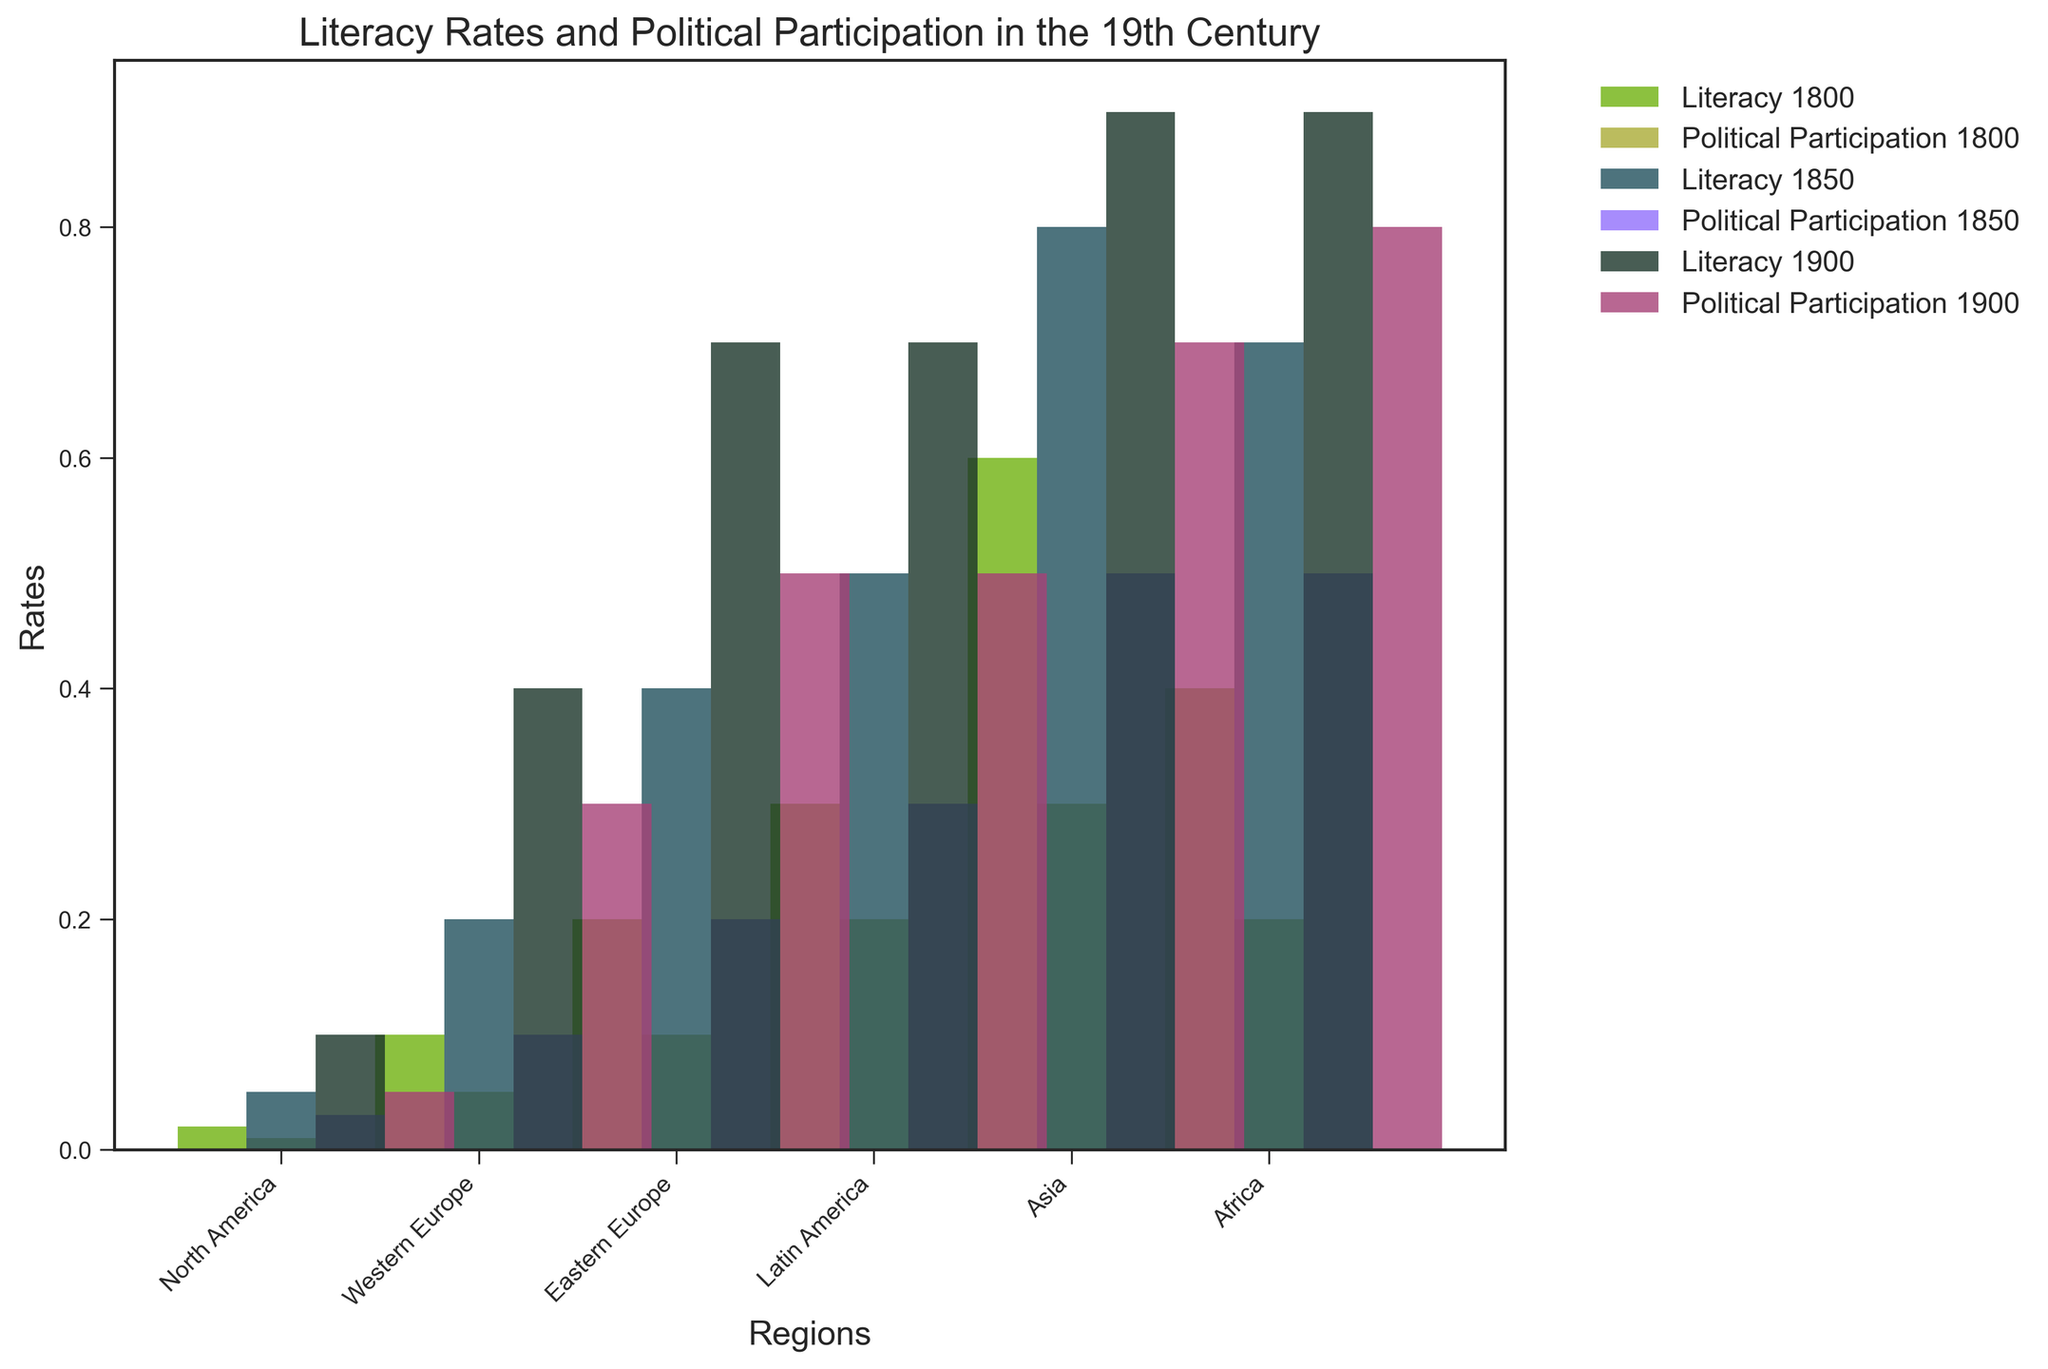What region had the highest literacy rate in 1900? To answer this question, look for the bars representing the literacy rates in 1900 across different regions. Compare the heights of these bars. The tallest bar indicates the highest literacy rate.
Answer: Western Europe Which region showed the greatest increase in political participation from 1800 to 1900? To identify this, examine the bars for political participation in each region for 1800 and 1900. Calculate the difference for each region and find the region with the largest difference.
Answer: Western Europe What was the combined literacy rate of Africa and Asia in 1850? Locate the literacy rate bars for Africa and Asia in 1850. Sum up the values represented by these bars.
Answer: 0.05 + 0.2 = 0.25 How does the literacy rate in North America in 1850 compare to Western Europe in the same year? Examine the literacy rate bars for North America and Western Europe in 1850. Compare their heights to determine which is higher.
Answer: North America By how much did political participation in Eastern Europe increase from 1850 to 1900? Identify the bars representing political participation in Eastern Europe for 1850 and 1900. Subtract the 1850 value from the 1900 value.
Answer: 0.5 - 0.2 = 0.3 What is the average literacy rate across all regions in 1800? Locate the literacy rate bars for all regions in 1800. Sum these values and divide by the number of regions.
Answer: (0.6 + 0.4 + 0.2 + 0.3 + 0.1 + 0.02) / 6 = 0.27 Was there a region where political participation did not improve significantly from 1800 to 1900? Compare the height of political participation bars in 1800 and 1900 for each region. Identify if any regions show minimal or no significant increase.
Answer: Africa Which region had the lowest political participation rate in 1850, and what was the rate? Look for the political participation bars in 1850. Determine the lowest bar and note the rate it represents.
Answer: Africa, 0.03 What are the visual differences between the literacy rate and political participation in Latin America in 1900? Compare the heights of the bars for literacy rate and political participation in Latin America for 1900. Note the differences in bar heights.
Answer: Literacy rate is higher 